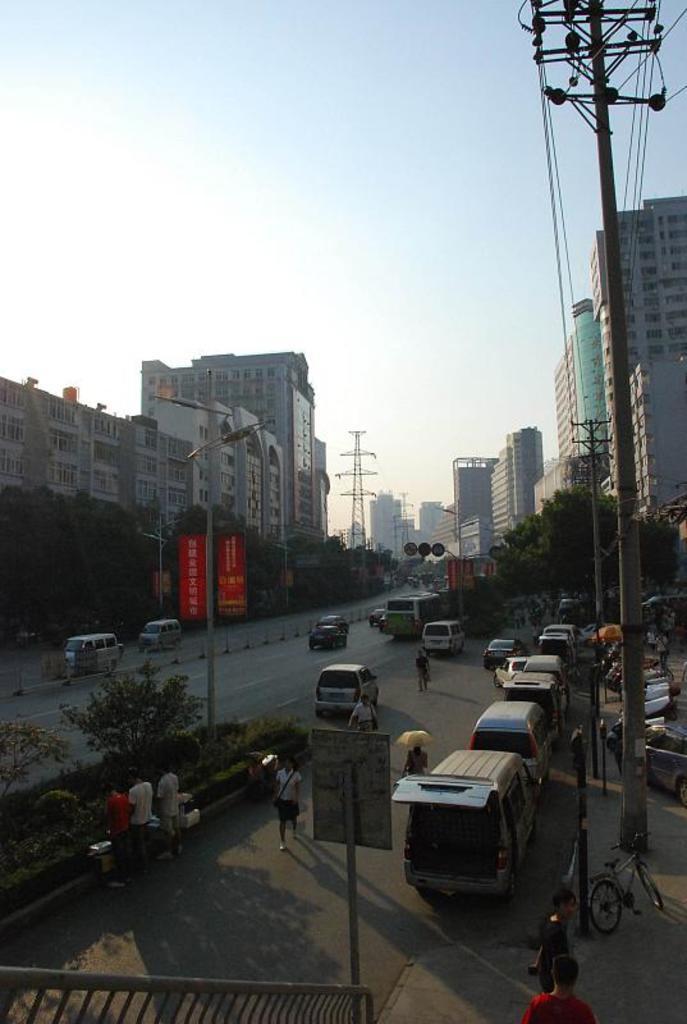Can you describe this image briefly? In the picture we can see a street with roads and on it we can see some vehicles and besides, we can see some trees to the path and buildings and in the background we can see some electric tower and sky. 